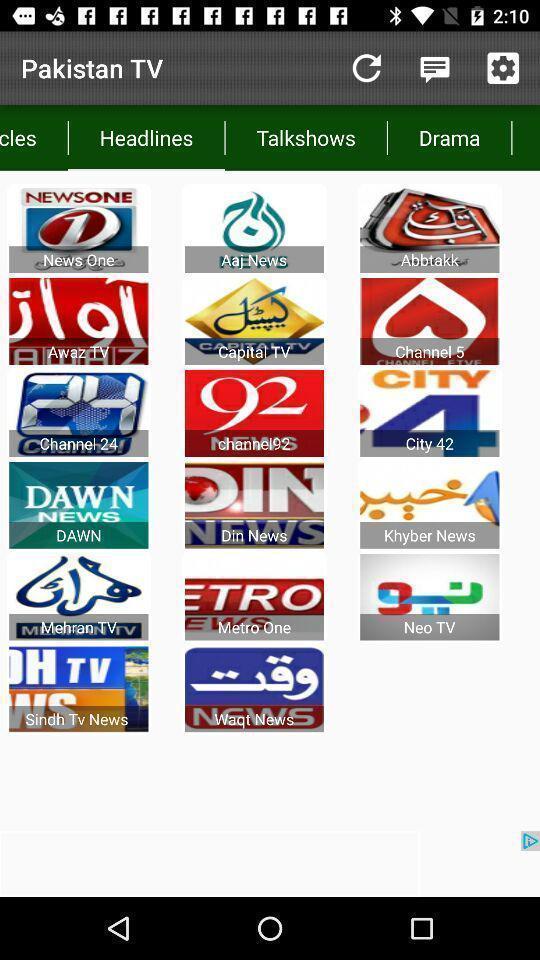What details can you identify in this image? Page displaying various news channels in news app. 